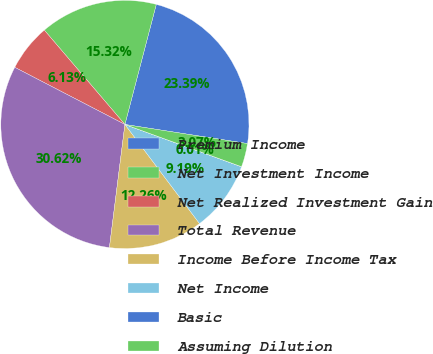Convert chart. <chart><loc_0><loc_0><loc_500><loc_500><pie_chart><fcel>Premium Income<fcel>Net Investment Income<fcel>Net Realized Investment Gain<fcel>Total Revenue<fcel>Income Before Income Tax<fcel>Net Income<fcel>Basic<fcel>Assuming Dilution<nl><fcel>23.39%<fcel>15.32%<fcel>6.13%<fcel>30.62%<fcel>12.26%<fcel>9.19%<fcel>0.01%<fcel>3.07%<nl></chart> 